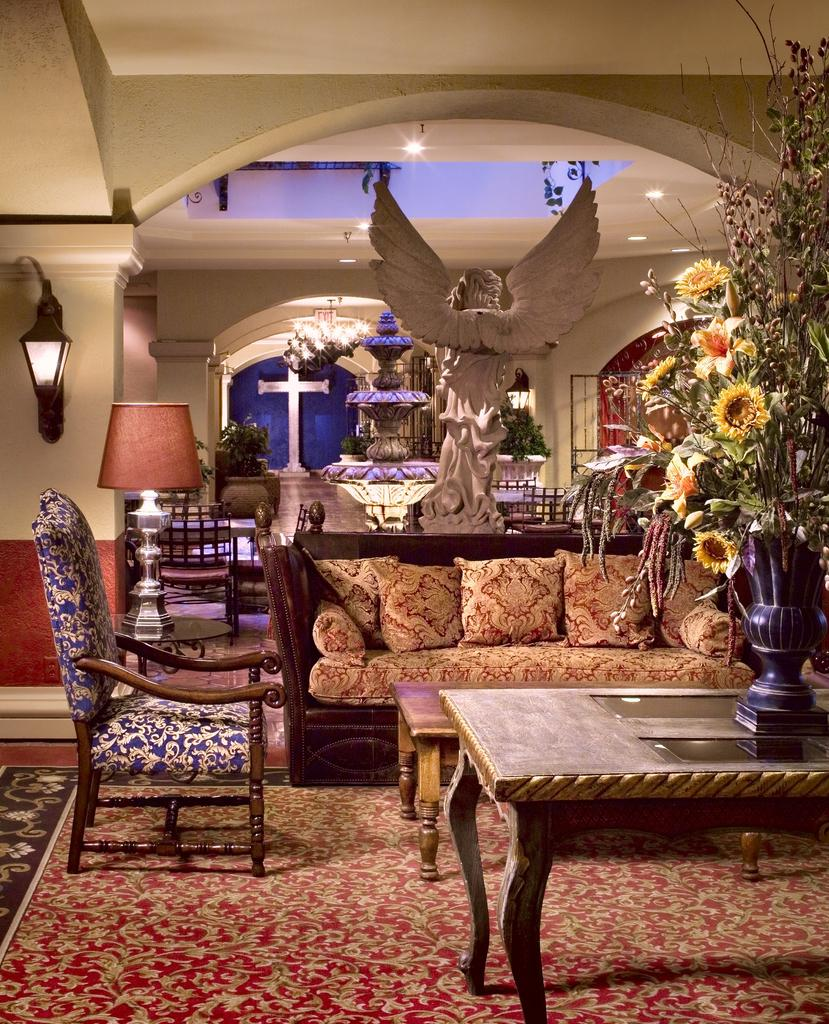What type of furniture is located on the right side of the room? There is a sofa and table on the right side of the room. What type of furniture is located on the left side of the room? There is a chair on the left side of the room. What can be seen in the background of the room? There is a lamp, a wall, a statue, and lights in the background. What type of yam is being used as a decoration on the chair? There is no yam present in the image, and therefore no such decoration can be observed. 